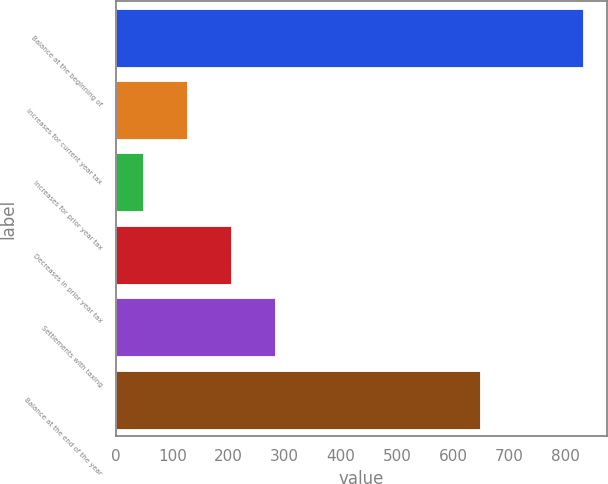Convert chart to OTSL. <chart><loc_0><loc_0><loc_500><loc_500><bar_chart><fcel>Balance at the beginning of<fcel>Increases for current year tax<fcel>Increases for prior year tax<fcel>Decreases in prior year tax<fcel>Settlements with taxing<fcel>Balance at the end of the year<nl><fcel>832<fcel>126.4<fcel>48<fcel>204.8<fcel>283.2<fcel>648<nl></chart> 